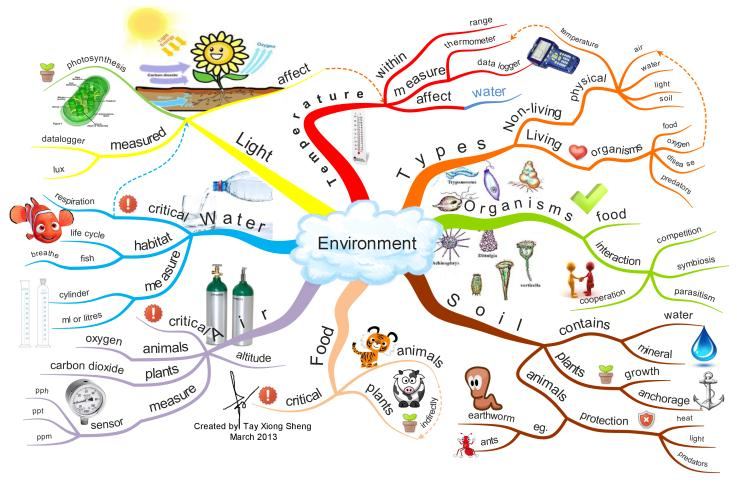Point out several critical features in this image. The two types of environment are non-living physical and living organisms, each with distinct characteristics and requirements. Soil contains water and minerals, which are essential for plant growth and health. The device used to measure temperature is a thermometer. Air is a vital source of oxygen for animals, which plants release into the atmosphere. Light is measured in units called lux, which is a unit of illuminance. 